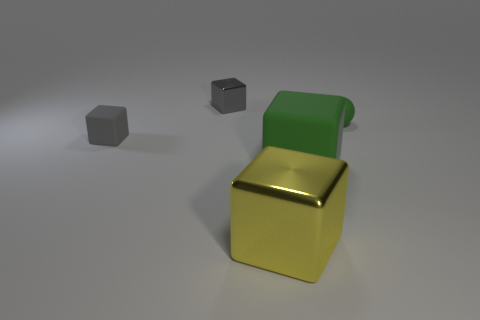How many things are green matte things that are behind the gray matte thing or rubber objects that are left of the large green cube?
Offer a very short reply. 2. How many other things are there of the same color as the tiny metal thing?
Give a very brief answer. 1. Is the number of tiny rubber cubes that are right of the tiny green matte thing less than the number of tiny green matte objects that are in front of the yellow block?
Offer a terse response. No. What number of large cyan matte cylinders are there?
Keep it short and to the point. 0. Are there any other things that are the same material as the small ball?
Provide a succinct answer. Yes. There is a big yellow object that is the same shape as the small gray metallic object; what material is it?
Make the answer very short. Metal. Is the number of tiny objects that are behind the big yellow metal cube less than the number of red metallic cylinders?
Provide a succinct answer. No. There is a shiny thing that is to the left of the big metal cube; is its shape the same as the small green matte thing?
Keep it short and to the point. No. Is there anything else that has the same color as the small matte sphere?
Ensure brevity in your answer.  Yes. There is a green block that is made of the same material as the ball; what is its size?
Offer a terse response. Large. 